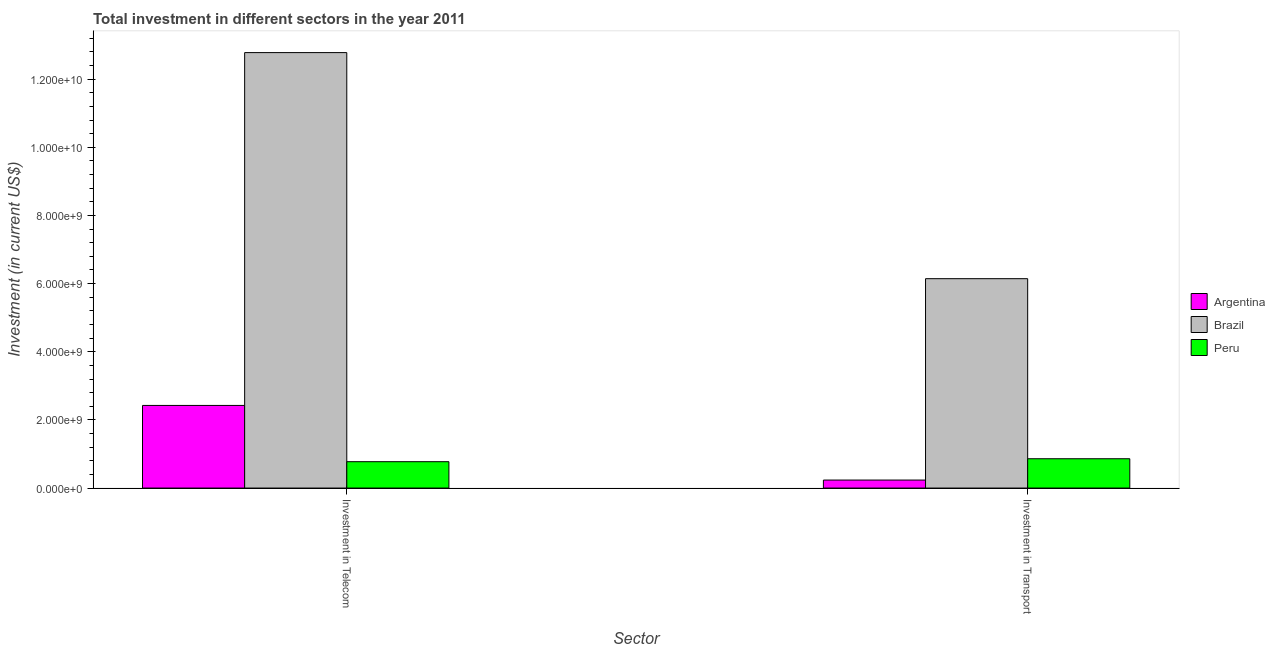How many groups of bars are there?
Keep it short and to the point. 2. Are the number of bars on each tick of the X-axis equal?
Ensure brevity in your answer.  Yes. How many bars are there on the 1st tick from the left?
Your answer should be very brief. 3. What is the label of the 2nd group of bars from the left?
Give a very brief answer. Investment in Transport. What is the investment in transport in Argentina?
Your response must be concise. 2.34e+08. Across all countries, what is the maximum investment in telecom?
Keep it short and to the point. 1.28e+1. Across all countries, what is the minimum investment in transport?
Give a very brief answer. 2.34e+08. What is the total investment in telecom in the graph?
Your response must be concise. 1.60e+1. What is the difference between the investment in transport in Peru and that in Brazil?
Give a very brief answer. -5.28e+09. What is the difference between the investment in transport in Argentina and the investment in telecom in Brazil?
Your answer should be compact. -1.25e+1. What is the average investment in telecom per country?
Offer a very short reply. 5.33e+09. What is the difference between the investment in telecom and investment in transport in Argentina?
Give a very brief answer. 2.19e+09. What is the ratio of the investment in transport in Brazil to that in Peru?
Make the answer very short. 7.15. In how many countries, is the investment in transport greater than the average investment in transport taken over all countries?
Provide a succinct answer. 1. What does the 1st bar from the left in Investment in Transport represents?
Give a very brief answer. Argentina. What is the difference between two consecutive major ticks on the Y-axis?
Your answer should be very brief. 2.00e+09. Are the values on the major ticks of Y-axis written in scientific E-notation?
Your answer should be compact. Yes. Does the graph contain any zero values?
Make the answer very short. No. How many legend labels are there?
Offer a very short reply. 3. What is the title of the graph?
Offer a terse response. Total investment in different sectors in the year 2011. Does "South Sudan" appear as one of the legend labels in the graph?
Make the answer very short. No. What is the label or title of the X-axis?
Make the answer very short. Sector. What is the label or title of the Y-axis?
Your answer should be compact. Investment (in current US$). What is the Investment (in current US$) in Argentina in Investment in Telecom?
Keep it short and to the point. 2.42e+09. What is the Investment (in current US$) in Brazil in Investment in Telecom?
Offer a very short reply. 1.28e+1. What is the Investment (in current US$) in Peru in Investment in Telecom?
Offer a terse response. 7.74e+08. What is the Investment (in current US$) of Argentina in Investment in Transport?
Your answer should be compact. 2.34e+08. What is the Investment (in current US$) in Brazil in Investment in Transport?
Provide a short and direct response. 6.14e+09. What is the Investment (in current US$) in Peru in Investment in Transport?
Your answer should be very brief. 8.60e+08. Across all Sector, what is the maximum Investment (in current US$) in Argentina?
Your answer should be very brief. 2.42e+09. Across all Sector, what is the maximum Investment (in current US$) in Brazil?
Provide a succinct answer. 1.28e+1. Across all Sector, what is the maximum Investment (in current US$) in Peru?
Offer a very short reply. 8.60e+08. Across all Sector, what is the minimum Investment (in current US$) of Argentina?
Make the answer very short. 2.34e+08. Across all Sector, what is the minimum Investment (in current US$) of Brazil?
Ensure brevity in your answer.  6.14e+09. Across all Sector, what is the minimum Investment (in current US$) in Peru?
Provide a short and direct response. 7.74e+08. What is the total Investment (in current US$) of Argentina in the graph?
Your answer should be compact. 2.66e+09. What is the total Investment (in current US$) in Brazil in the graph?
Provide a short and direct response. 1.89e+1. What is the total Investment (in current US$) of Peru in the graph?
Your answer should be very brief. 1.63e+09. What is the difference between the Investment (in current US$) of Argentina in Investment in Telecom and that in Investment in Transport?
Provide a succinct answer. 2.19e+09. What is the difference between the Investment (in current US$) of Brazil in Investment in Telecom and that in Investment in Transport?
Keep it short and to the point. 6.64e+09. What is the difference between the Investment (in current US$) in Peru in Investment in Telecom and that in Investment in Transport?
Your response must be concise. -8.64e+07. What is the difference between the Investment (in current US$) of Argentina in Investment in Telecom and the Investment (in current US$) of Brazil in Investment in Transport?
Offer a terse response. -3.72e+09. What is the difference between the Investment (in current US$) in Argentina in Investment in Telecom and the Investment (in current US$) in Peru in Investment in Transport?
Offer a very short reply. 1.56e+09. What is the difference between the Investment (in current US$) of Brazil in Investment in Telecom and the Investment (in current US$) of Peru in Investment in Transport?
Your response must be concise. 1.19e+1. What is the average Investment (in current US$) in Argentina per Sector?
Provide a succinct answer. 1.33e+09. What is the average Investment (in current US$) of Brazil per Sector?
Your answer should be very brief. 9.46e+09. What is the average Investment (in current US$) in Peru per Sector?
Offer a very short reply. 8.17e+08. What is the difference between the Investment (in current US$) in Argentina and Investment (in current US$) in Brazil in Investment in Telecom?
Your response must be concise. -1.04e+1. What is the difference between the Investment (in current US$) in Argentina and Investment (in current US$) in Peru in Investment in Telecom?
Your answer should be very brief. 1.65e+09. What is the difference between the Investment (in current US$) in Brazil and Investment (in current US$) in Peru in Investment in Telecom?
Provide a short and direct response. 1.20e+1. What is the difference between the Investment (in current US$) in Argentina and Investment (in current US$) in Brazil in Investment in Transport?
Keep it short and to the point. -5.91e+09. What is the difference between the Investment (in current US$) of Argentina and Investment (in current US$) of Peru in Investment in Transport?
Provide a short and direct response. -6.26e+08. What is the difference between the Investment (in current US$) in Brazil and Investment (in current US$) in Peru in Investment in Transport?
Offer a terse response. 5.28e+09. What is the ratio of the Investment (in current US$) of Argentina in Investment in Telecom to that in Investment in Transport?
Make the answer very short. 10.34. What is the ratio of the Investment (in current US$) of Brazil in Investment in Telecom to that in Investment in Transport?
Provide a succinct answer. 2.08. What is the ratio of the Investment (in current US$) in Peru in Investment in Telecom to that in Investment in Transport?
Your response must be concise. 0.9. What is the difference between the highest and the second highest Investment (in current US$) in Argentina?
Give a very brief answer. 2.19e+09. What is the difference between the highest and the second highest Investment (in current US$) in Brazil?
Your answer should be compact. 6.64e+09. What is the difference between the highest and the second highest Investment (in current US$) of Peru?
Provide a short and direct response. 8.64e+07. What is the difference between the highest and the lowest Investment (in current US$) of Argentina?
Ensure brevity in your answer.  2.19e+09. What is the difference between the highest and the lowest Investment (in current US$) in Brazil?
Offer a terse response. 6.64e+09. What is the difference between the highest and the lowest Investment (in current US$) of Peru?
Your answer should be compact. 8.64e+07. 